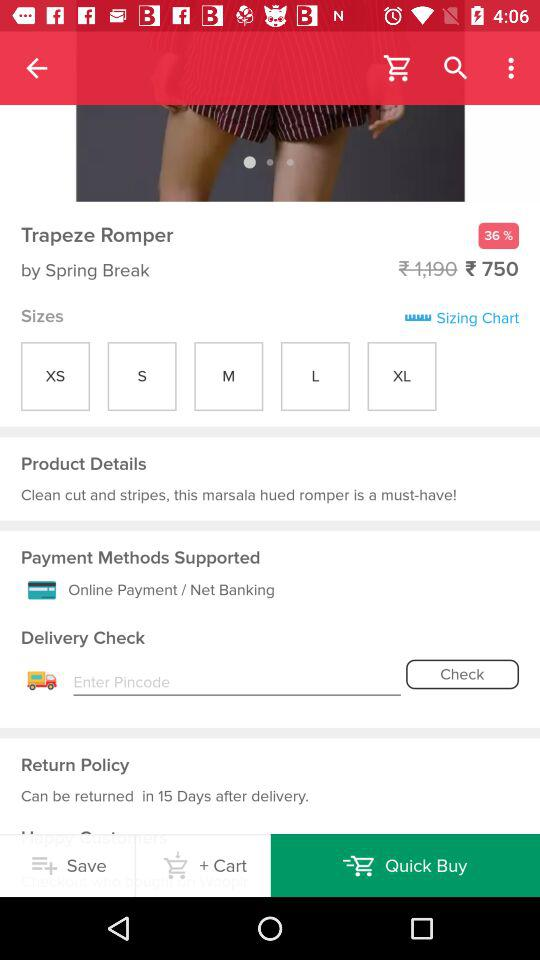Which tab is selected? The selected tab is "Quick Buy". 